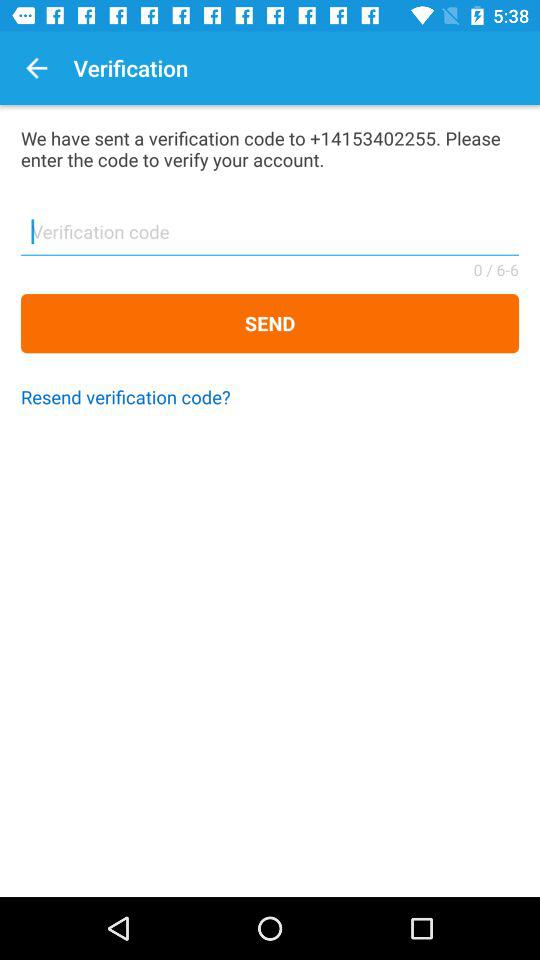What contact number is used to verify the account? The contact number is +14153402255. 